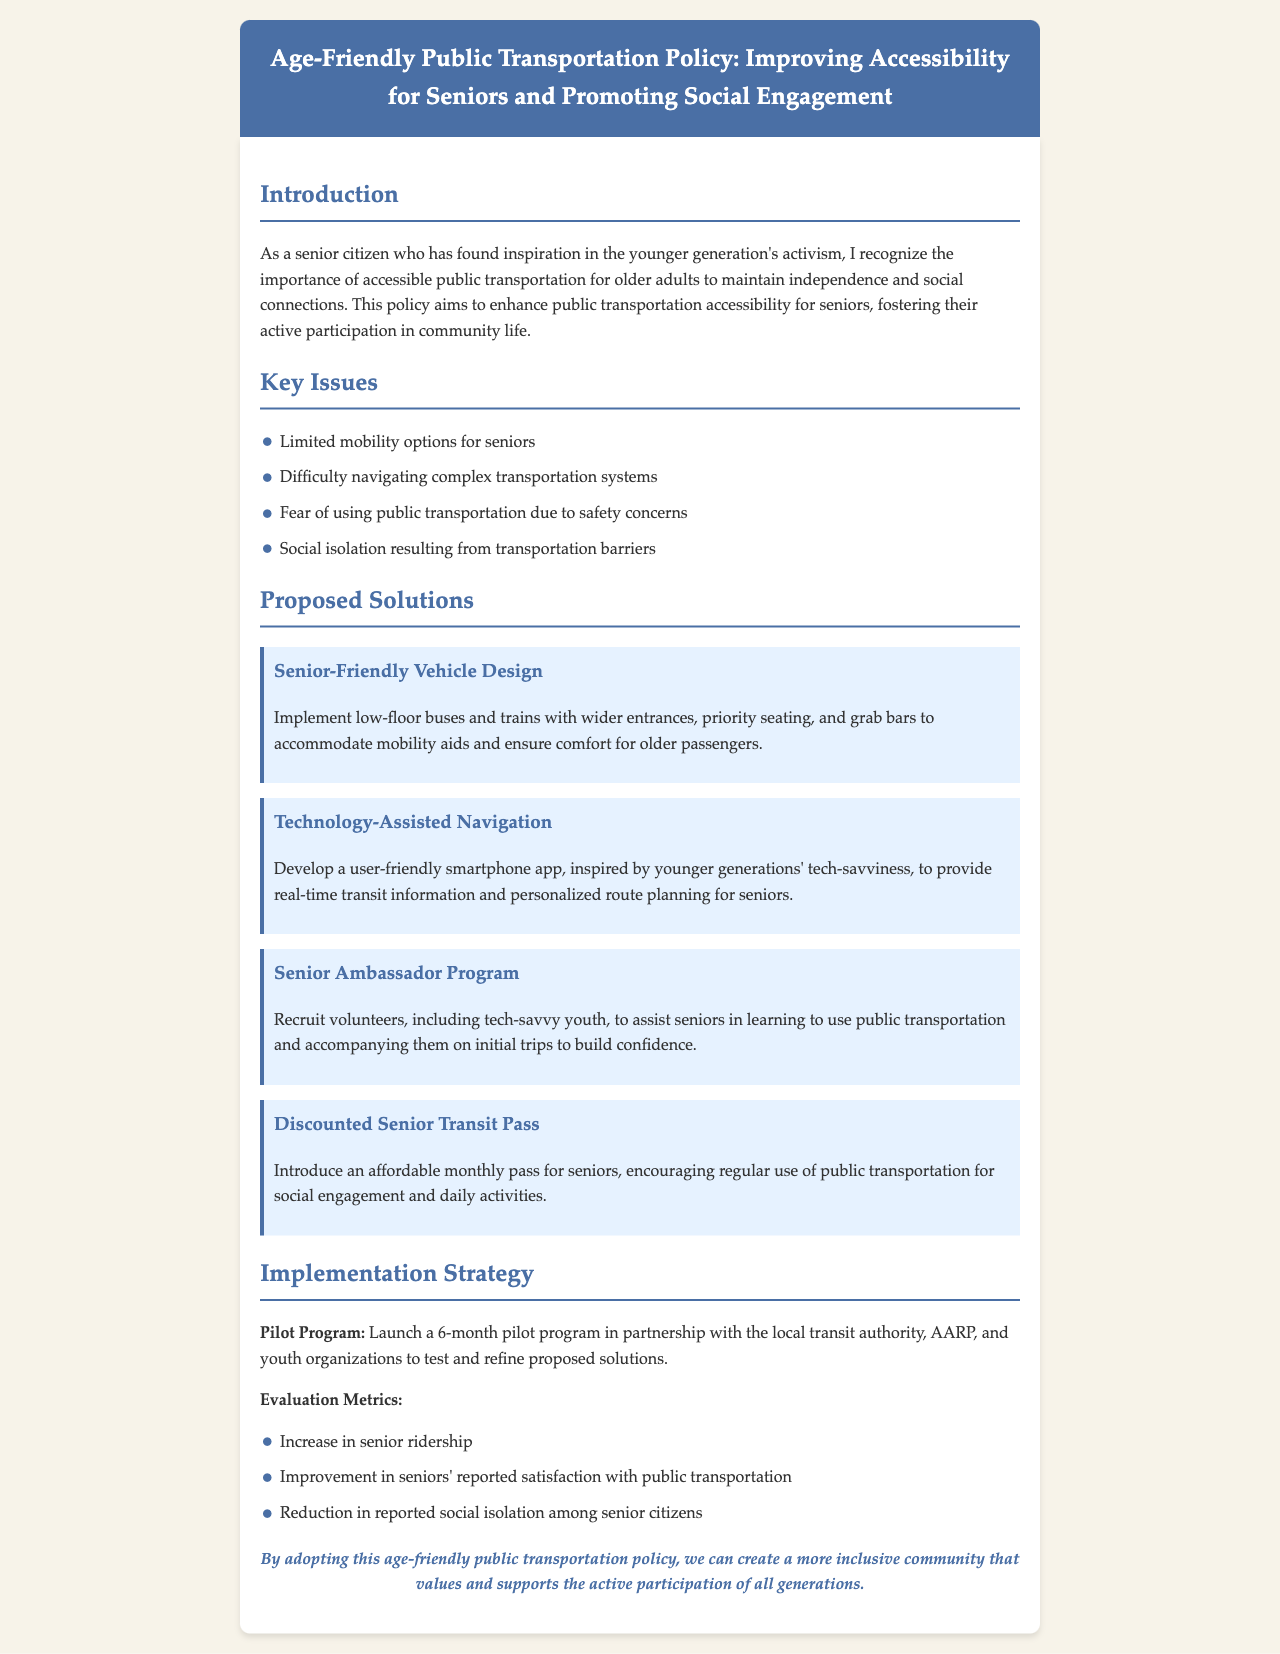What is the title of the policy? The title of the policy document is mentioned at the very top.
Answer: Age-Friendly Public Transportation Policy: Improving Accessibility for Seniors and Promoting Social Engagement What is one key issue identified in the document? The document lists several key issues regarding public transportation for seniors.
Answer: Limited mobility options for seniors What is one proposed solution for improving transportation? The document outlines various solutions to enhance transportation for seniors.
Answer: Senior-Friendly Vehicle Design How long is the pilot program planned to last? The duration of the pilot program is specified in the implementation strategy section.
Answer: 6 months What metrics will be used to evaluate the program? The document lists evaluation metrics for assessing the pilot program's effectiveness.
Answer: Increase in senior ridership Who is involved in the pilot program? The implementation strategy section outlines the partners for the pilot program.
Answer: Local transit authority, AARP, and youth organizations What type of app is suggested for seniors? The document describes a specific type of app aimed at assisting seniors.
Answer: User-friendly smartphone app What is the aim of the Senior Ambassador Program? The program's objective is detailed in the proposed solutions.
Answer: Assist seniors in learning to use public transportation 